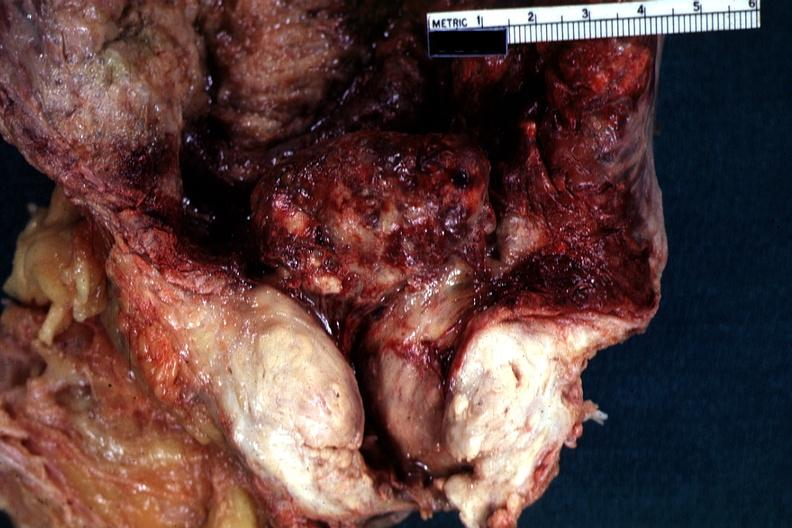s prostate present?
Answer the question using a single word or phrase. Yes 